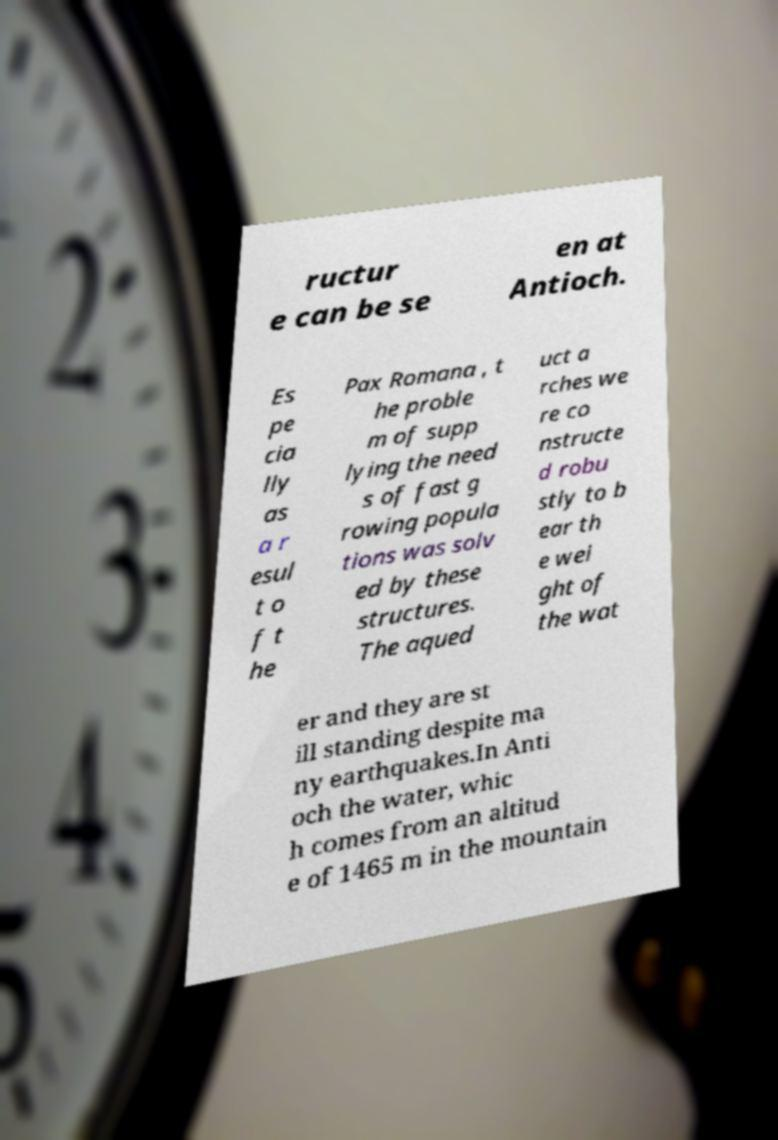Please read and relay the text visible in this image. What does it say? ructur e can be se en at Antioch. Es pe cia lly as a r esul t o f t he Pax Romana , t he proble m of supp lying the need s of fast g rowing popula tions was solv ed by these structures. The aqued uct a rches we re co nstructe d robu stly to b ear th e wei ght of the wat er and they are st ill standing despite ma ny earthquakes.In Anti och the water, whic h comes from an altitud e of 1465 m in the mountain 